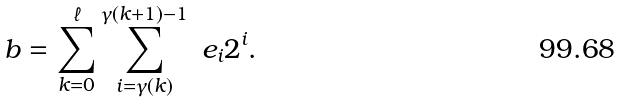Convert formula to latex. <formula><loc_0><loc_0><loc_500><loc_500>b = \sum _ { k = 0 } ^ { \ell } \sum _ { i = \gamma ( k ) } ^ { \gamma ( k + 1 ) - 1 } \ e _ { i } 2 ^ { i } .</formula> 